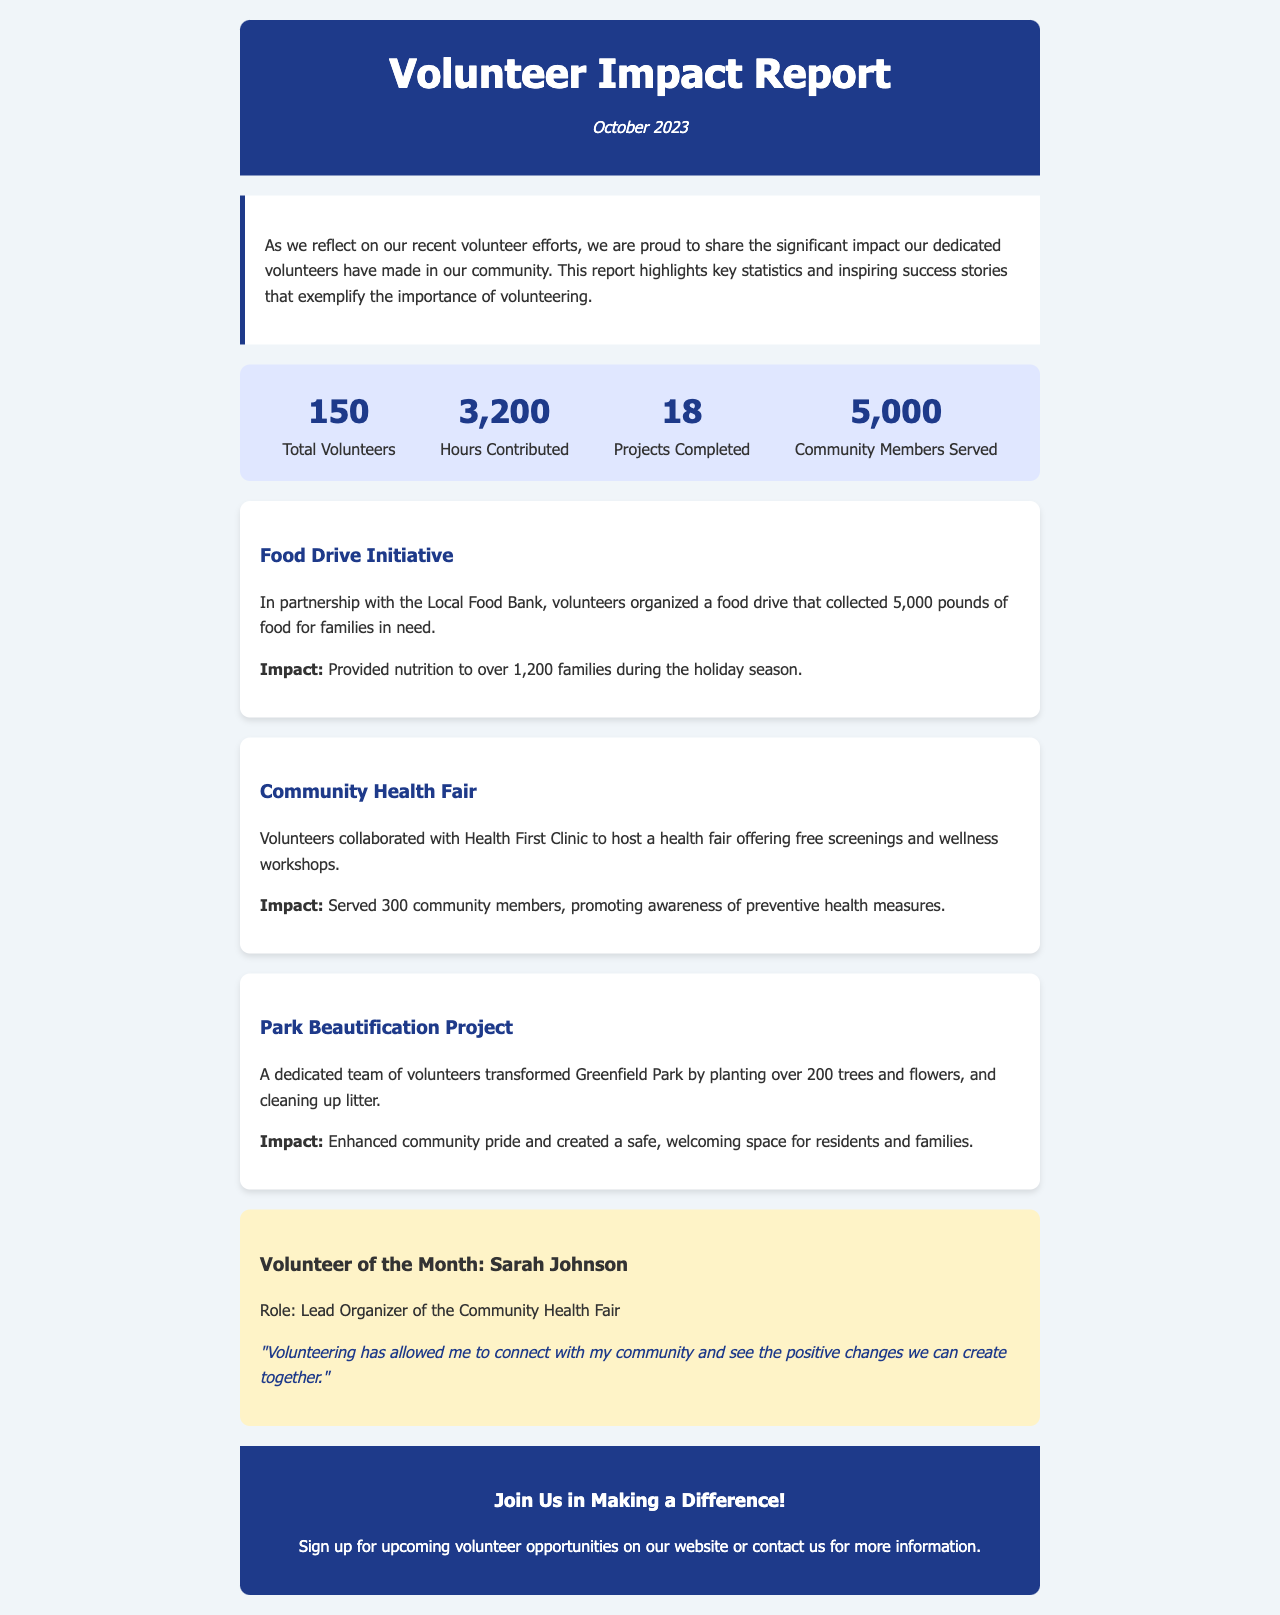What is the total number of volunteers? The total number of volunteers is stated as 150 in the document.
Answer: 150 How many hours were contributed by volunteers? The document indicates that volunteers contributed a total of 3,200 hours.
Answer: 3,200 What is the name of the Volunteer of the Month? The name of the Volunteer of the Month mentioned in the document is Sarah Johnson.
Answer: Sarah Johnson How many projects were completed? The document states that 18 projects were completed by volunteers.
Answer: 18 What was the primary impact of the Food Drive Initiative? The impact highlighted in the document is that it provided nutrition to over 1,200 families.
Answer: Over 1,200 families Which health organization collaborated for the Community Health Fair? The organization mentioned is Health First Clinic as per the document.
Answer: Health First Clinic What did the volunteers accomplish in Greenfield Park? The volunteers transformed the park by planting over 200 trees and flowers, according to the document.
Answer: Over 200 trees and flowers In which month is the Volunteer Impact Report published? The document states that the report is published in October 2023.
Answer: October 2023 What event did the volunteers organize in partnership with the Local Food Bank? The document mentions a food drive as the event organized in partnership with the Local Food Bank.
Answer: Food Drive 